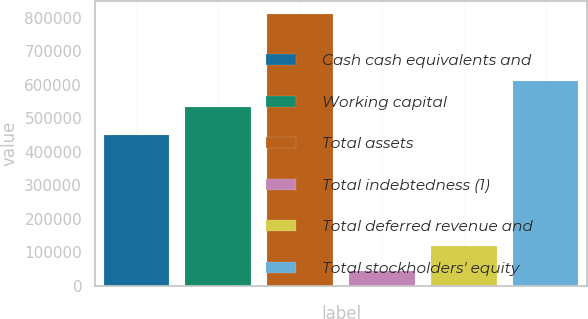Convert chart to OTSL. <chart><loc_0><loc_0><loc_500><loc_500><bar_chart><fcel>Cash cash equivalents and<fcel>Working capital<fcel>Total assets<fcel>Total indebtedness (1)<fcel>Total deferred revenue and<fcel>Total stockholders' equity<nl><fcel>449457<fcel>535106<fcel>811023<fcel>43634<fcel>120373<fcel>611845<nl></chart> 